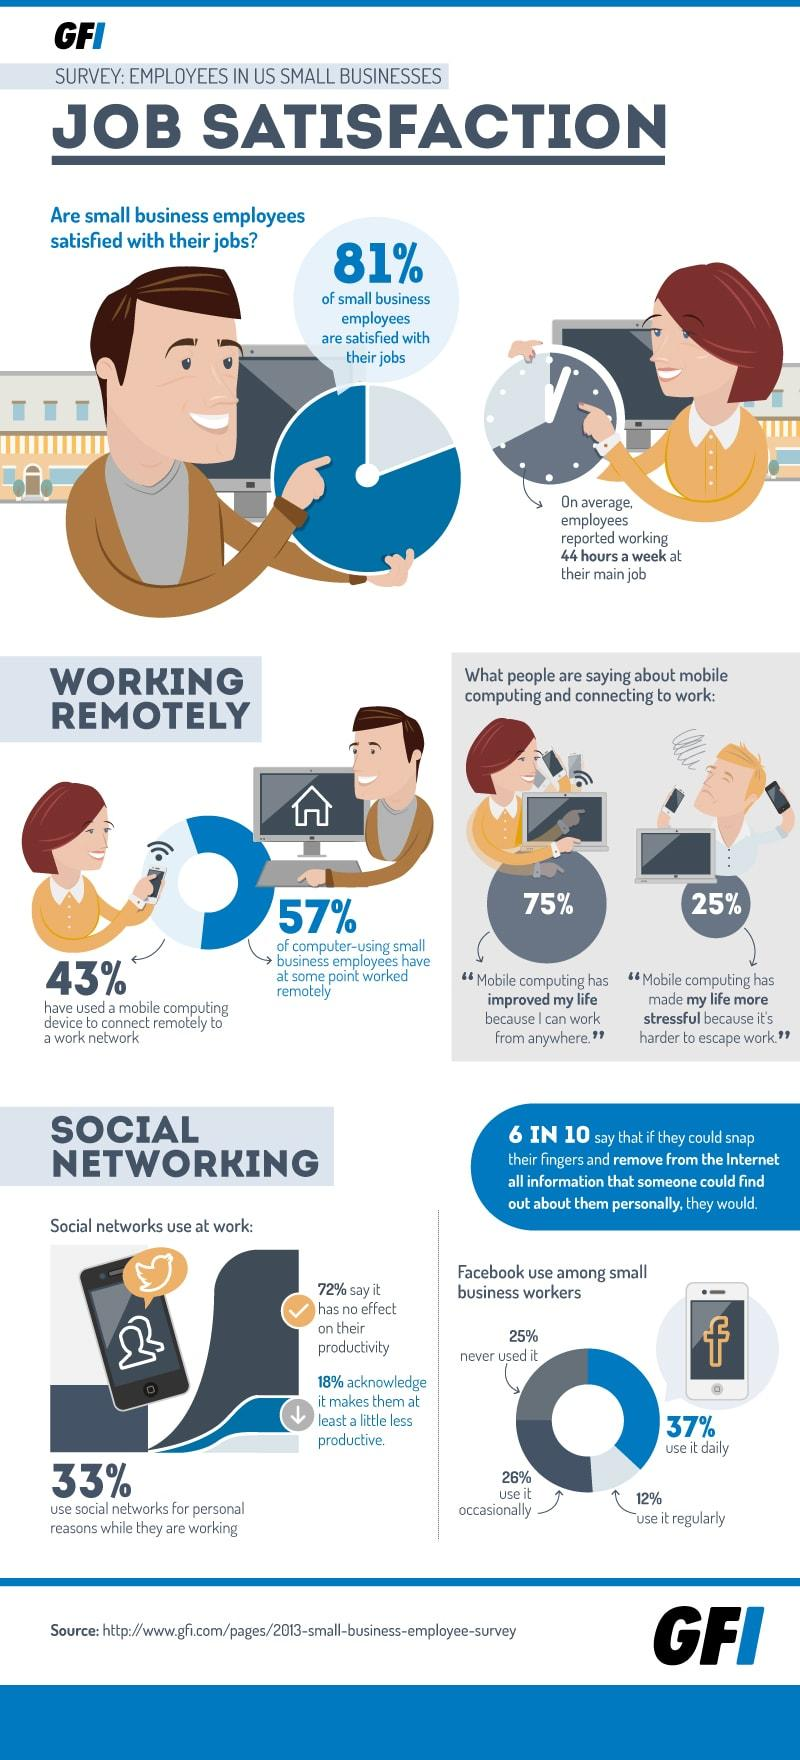Outline some significant characteristics in this image. According to a recent survey, 19% of small business employees are not satisfied with their jobs. According to a study, 37% of small business workers use Facebook daily. According to a recent survey, 75% of people believe that mobile computing is favorable because it allows them to work from anywhere. 